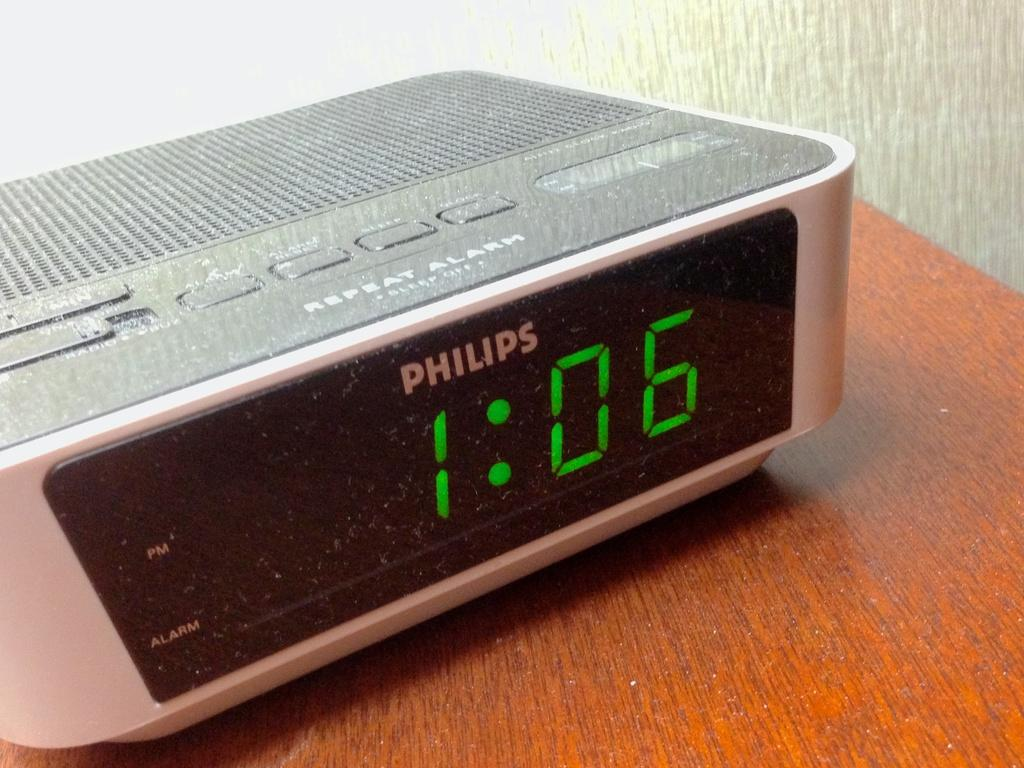Provide a one-sentence caption for the provided image. The Philips digital clock says the time is 1:06. 